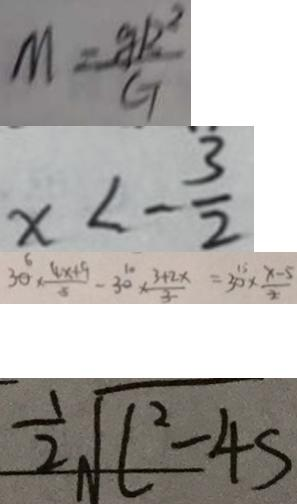<formula> <loc_0><loc_0><loc_500><loc_500>M = \frac { g k ^ { 2 } } { G } 
 x < - \frac { 3 } { 2 } 
 3 0 \times \frac { 4 x + 9 } { 5 } - 3 0 \times \frac { 3 + 2 x } { 3 } = 3 0 \times \frac { x - 5 } { 2 } 
 \frac { 1 } { 2 } \sqrt { l ^ { 2 } - 4 s }</formula> 